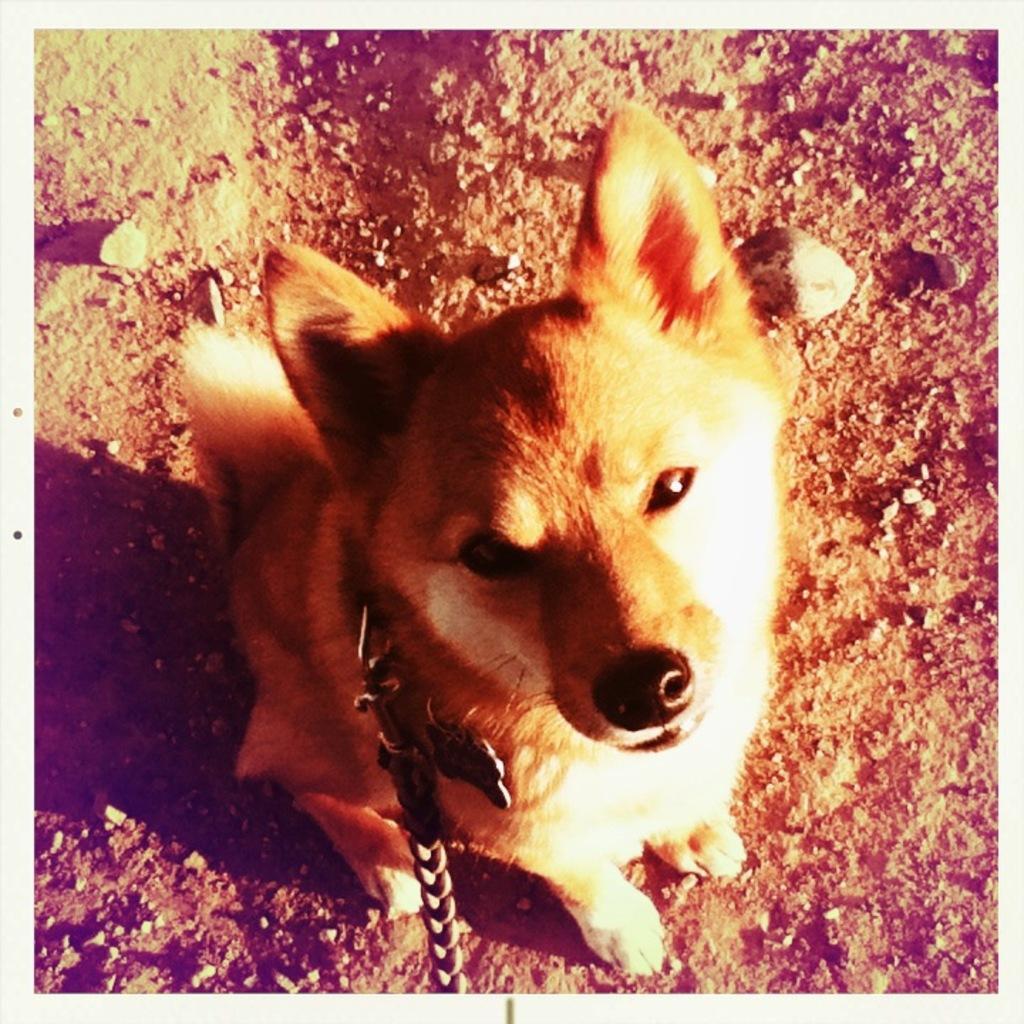In one or two sentences, can you explain what this image depicts? In this picture we can see a dog, and it is tied with a chain. 